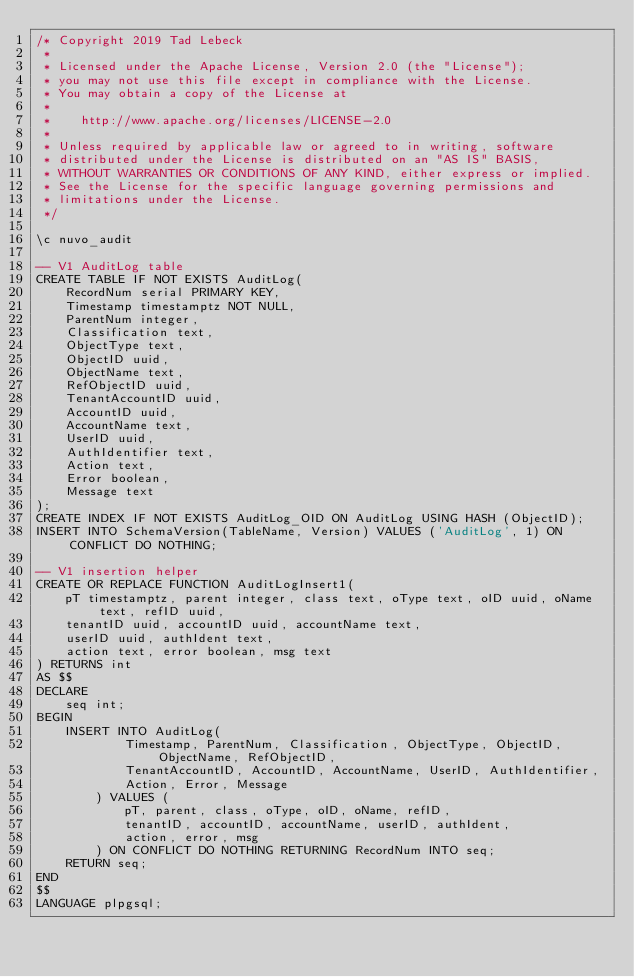<code> <loc_0><loc_0><loc_500><loc_500><_SQL_>/* Copyright 2019 Tad Lebeck
 *
 * Licensed under the Apache License, Version 2.0 (the "License");
 * you may not use this file except in compliance with the License.
 * You may obtain a copy of the License at
 *
 *    http://www.apache.org/licenses/LICENSE-2.0
 *
 * Unless required by applicable law or agreed to in writing, software
 * distributed under the License is distributed on an "AS IS" BASIS,
 * WITHOUT WARRANTIES OR CONDITIONS OF ANY KIND, either express or implied.
 * See the License for the specific language governing permissions and
 * limitations under the License.
 */

\c nuvo_audit

-- V1 AuditLog table
CREATE TABLE IF NOT EXISTS AuditLog(
    RecordNum serial PRIMARY KEY,
    Timestamp timestamptz NOT NULL,
    ParentNum integer,
    Classification text,
    ObjectType text,
    ObjectID uuid,
    ObjectName text,
    RefObjectID uuid,
    TenantAccountID uuid,
    AccountID uuid,
    AccountName text,
    UserID uuid,
    AuthIdentifier text,
    Action text,
    Error boolean,
    Message text
);
CREATE INDEX IF NOT EXISTS AuditLog_OID ON AuditLog USING HASH (ObjectID);
INSERT INTO SchemaVersion(TableName, Version) VALUES ('AuditLog', 1) ON CONFLICT DO NOTHING;

-- V1 insertion helper
CREATE OR REPLACE FUNCTION AuditLogInsert1(
    pT timestamptz, parent integer, class text, oType text, oID uuid, oName text, refID uuid,
    tenantID uuid, accountID uuid, accountName text,
    userID uuid, authIdent text,
    action text, error boolean, msg text
) RETURNS int
AS $$
DECLARE
    seq int;
BEGIN
    INSERT INTO AuditLog(
            Timestamp, ParentNum, Classification, ObjectType, ObjectID, ObjectName, RefObjectID,
            TenantAccountID, AccountID, AccountName, UserID, AuthIdentifier,
            Action, Error, Message
        ) VALUES (
            pT, parent, class, oType, oID, oName, refID,
            tenantID, accountID, accountName, userID, authIdent,
            action, error, msg
        ) ON CONFLICT DO NOTHING RETURNING RecordNum INTO seq;
    RETURN seq;
END
$$
LANGUAGE plpgsql;
</code> 